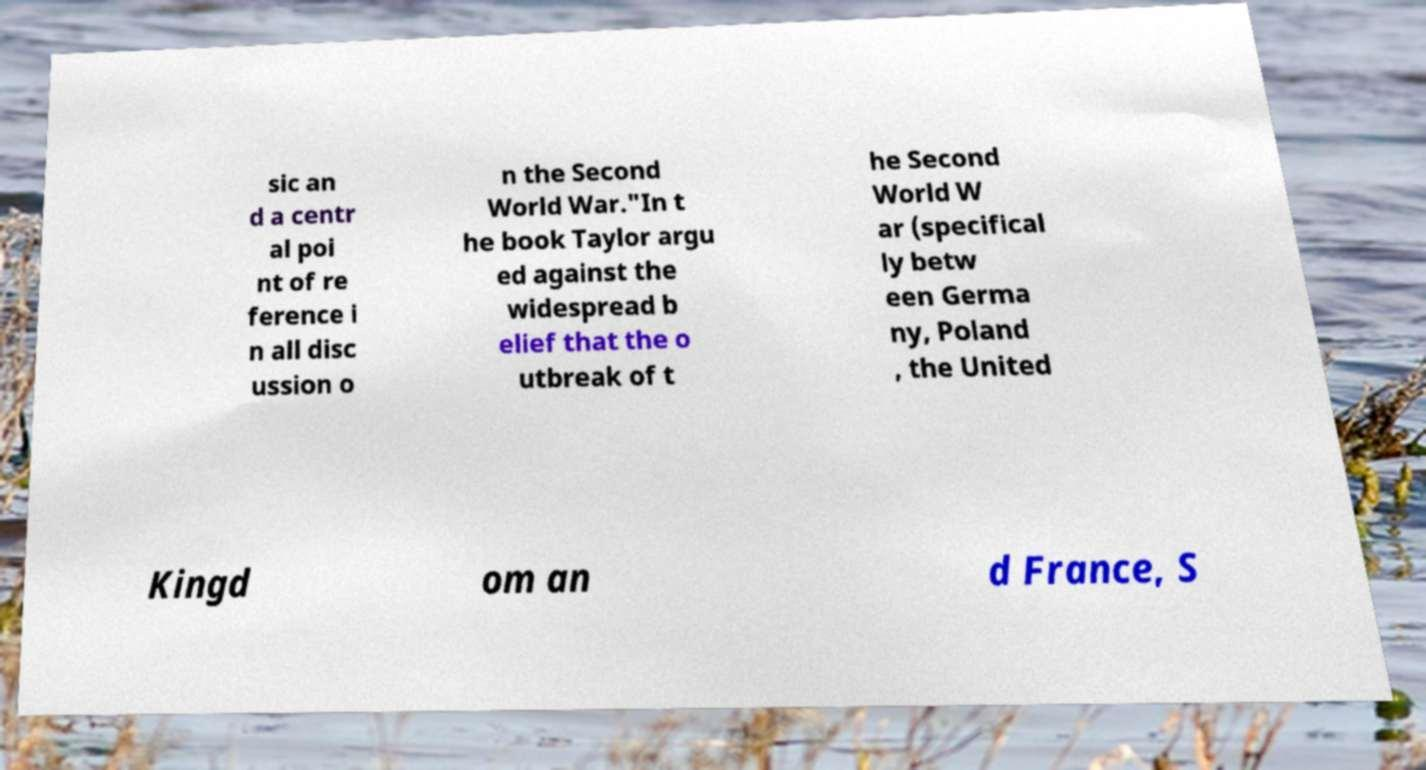What messages or text are displayed in this image? I need them in a readable, typed format. sic an d a centr al poi nt of re ference i n all disc ussion o n the Second World War."In t he book Taylor argu ed against the widespread b elief that the o utbreak of t he Second World W ar (specifical ly betw een Germa ny, Poland , the United Kingd om an d France, S 